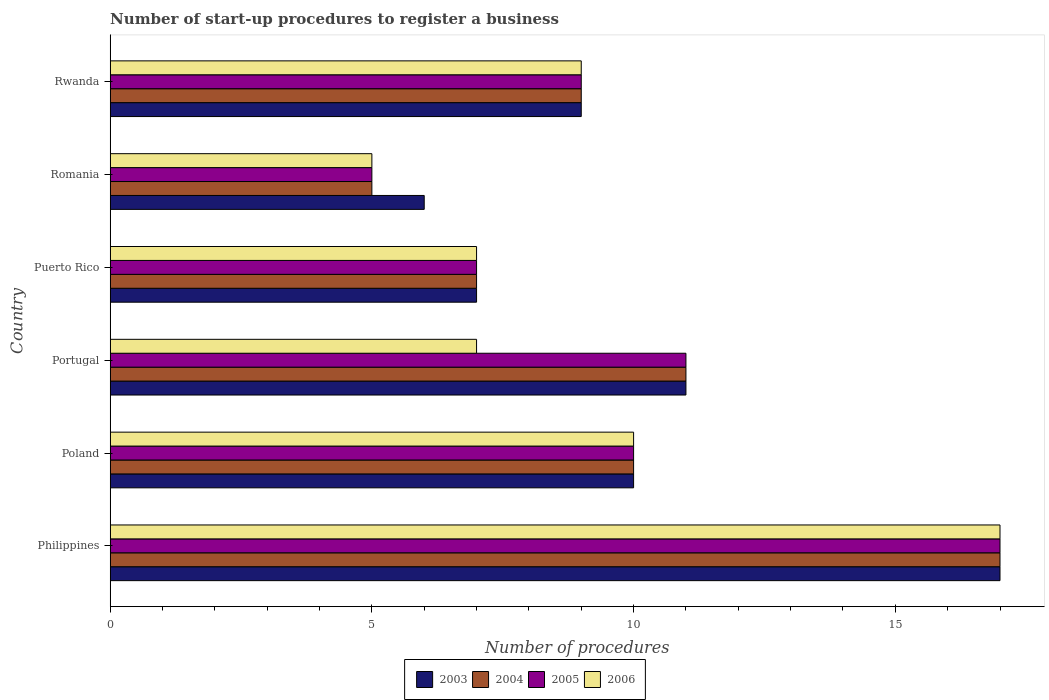How many groups of bars are there?
Offer a terse response. 6. Are the number of bars per tick equal to the number of legend labels?
Offer a very short reply. Yes. How many bars are there on the 4th tick from the top?
Keep it short and to the point. 4. How many bars are there on the 2nd tick from the bottom?
Your answer should be compact. 4. What is the label of the 2nd group of bars from the top?
Make the answer very short. Romania. Across all countries, what is the maximum number of procedures required to register a business in 2004?
Ensure brevity in your answer.  17. Across all countries, what is the minimum number of procedures required to register a business in 2006?
Your answer should be very brief. 5. In which country was the number of procedures required to register a business in 2003 maximum?
Offer a terse response. Philippines. In which country was the number of procedures required to register a business in 2004 minimum?
Your answer should be compact. Romania. What is the total number of procedures required to register a business in 2004 in the graph?
Provide a short and direct response. 59. What is the difference between the number of procedures required to register a business in 2005 in Poland and that in Portugal?
Your response must be concise. -1. What is the difference between the number of procedures required to register a business in 2005 in Poland and the number of procedures required to register a business in 2003 in Philippines?
Make the answer very short. -7. What is the average number of procedures required to register a business in 2004 per country?
Keep it short and to the point. 9.83. What is the ratio of the number of procedures required to register a business in 2003 in Poland to that in Portugal?
Your response must be concise. 0.91. Is the difference between the number of procedures required to register a business in 2004 in Romania and Rwanda greater than the difference between the number of procedures required to register a business in 2005 in Romania and Rwanda?
Provide a short and direct response. No. What is the difference between the highest and the second highest number of procedures required to register a business in 2005?
Make the answer very short. 6. Is the sum of the number of procedures required to register a business in 2005 in Puerto Rico and Romania greater than the maximum number of procedures required to register a business in 2003 across all countries?
Keep it short and to the point. No. Is it the case that in every country, the sum of the number of procedures required to register a business in 2005 and number of procedures required to register a business in 2006 is greater than the sum of number of procedures required to register a business in 2003 and number of procedures required to register a business in 2004?
Your response must be concise. No. Is it the case that in every country, the sum of the number of procedures required to register a business in 2005 and number of procedures required to register a business in 2004 is greater than the number of procedures required to register a business in 2006?
Make the answer very short. Yes. How many bars are there?
Provide a succinct answer. 24. What is the difference between two consecutive major ticks on the X-axis?
Ensure brevity in your answer.  5. Are the values on the major ticks of X-axis written in scientific E-notation?
Your answer should be compact. No. Does the graph contain grids?
Ensure brevity in your answer.  No. How are the legend labels stacked?
Your answer should be very brief. Horizontal. What is the title of the graph?
Your answer should be very brief. Number of start-up procedures to register a business. Does "1983" appear as one of the legend labels in the graph?
Keep it short and to the point. No. What is the label or title of the X-axis?
Offer a terse response. Number of procedures. What is the label or title of the Y-axis?
Provide a succinct answer. Country. What is the Number of procedures of 2004 in Philippines?
Ensure brevity in your answer.  17. What is the Number of procedures in 2005 in Philippines?
Provide a short and direct response. 17. What is the Number of procedures in 2006 in Philippines?
Keep it short and to the point. 17. What is the Number of procedures of 2004 in Poland?
Give a very brief answer. 10. What is the Number of procedures of 2004 in Portugal?
Your answer should be very brief. 11. What is the Number of procedures of 2006 in Puerto Rico?
Offer a terse response. 7. What is the Number of procedures of 2003 in Romania?
Ensure brevity in your answer.  6. What is the Number of procedures in 2004 in Romania?
Your answer should be compact. 5. What is the Number of procedures in 2006 in Romania?
Provide a short and direct response. 5. What is the Number of procedures of 2003 in Rwanda?
Your answer should be compact. 9. What is the Number of procedures in 2004 in Rwanda?
Make the answer very short. 9. What is the Number of procedures of 2005 in Rwanda?
Ensure brevity in your answer.  9. What is the Number of procedures in 2006 in Rwanda?
Offer a very short reply. 9. Across all countries, what is the maximum Number of procedures in 2005?
Provide a short and direct response. 17. Across all countries, what is the minimum Number of procedures in 2004?
Your response must be concise. 5. Across all countries, what is the minimum Number of procedures of 2005?
Provide a succinct answer. 5. Across all countries, what is the minimum Number of procedures in 2006?
Ensure brevity in your answer.  5. What is the total Number of procedures in 2006 in the graph?
Your answer should be compact. 55. What is the difference between the Number of procedures in 2003 in Philippines and that in Poland?
Offer a terse response. 7. What is the difference between the Number of procedures of 2004 in Philippines and that in Poland?
Offer a terse response. 7. What is the difference between the Number of procedures of 2006 in Philippines and that in Poland?
Give a very brief answer. 7. What is the difference between the Number of procedures of 2003 in Philippines and that in Portugal?
Offer a very short reply. 6. What is the difference between the Number of procedures of 2005 in Philippines and that in Portugal?
Your response must be concise. 6. What is the difference between the Number of procedures of 2006 in Philippines and that in Portugal?
Give a very brief answer. 10. What is the difference between the Number of procedures in 2003 in Philippines and that in Puerto Rico?
Your answer should be very brief. 10. What is the difference between the Number of procedures of 2006 in Philippines and that in Romania?
Give a very brief answer. 12. What is the difference between the Number of procedures of 2004 in Philippines and that in Rwanda?
Give a very brief answer. 8. What is the difference between the Number of procedures in 2006 in Philippines and that in Rwanda?
Give a very brief answer. 8. What is the difference between the Number of procedures of 2003 in Poland and that in Portugal?
Provide a short and direct response. -1. What is the difference between the Number of procedures of 2004 in Poland and that in Portugal?
Your answer should be compact. -1. What is the difference between the Number of procedures in 2005 in Poland and that in Portugal?
Make the answer very short. -1. What is the difference between the Number of procedures in 2006 in Poland and that in Portugal?
Your answer should be compact. 3. What is the difference between the Number of procedures in 2003 in Poland and that in Puerto Rico?
Keep it short and to the point. 3. What is the difference between the Number of procedures in 2005 in Poland and that in Puerto Rico?
Keep it short and to the point. 3. What is the difference between the Number of procedures in 2003 in Poland and that in Romania?
Offer a very short reply. 4. What is the difference between the Number of procedures of 2006 in Poland and that in Romania?
Provide a succinct answer. 5. What is the difference between the Number of procedures of 2003 in Poland and that in Rwanda?
Provide a short and direct response. 1. What is the difference between the Number of procedures of 2004 in Poland and that in Rwanda?
Provide a short and direct response. 1. What is the difference between the Number of procedures in 2005 in Poland and that in Rwanda?
Make the answer very short. 1. What is the difference between the Number of procedures in 2006 in Poland and that in Rwanda?
Your answer should be compact. 1. What is the difference between the Number of procedures of 2006 in Portugal and that in Puerto Rico?
Offer a terse response. 0. What is the difference between the Number of procedures in 2006 in Portugal and that in Romania?
Keep it short and to the point. 2. What is the difference between the Number of procedures in 2004 in Portugal and that in Rwanda?
Keep it short and to the point. 2. What is the difference between the Number of procedures of 2005 in Portugal and that in Rwanda?
Offer a terse response. 2. What is the difference between the Number of procedures of 2006 in Portugal and that in Rwanda?
Provide a succinct answer. -2. What is the difference between the Number of procedures of 2003 in Puerto Rico and that in Romania?
Provide a short and direct response. 1. What is the difference between the Number of procedures of 2005 in Puerto Rico and that in Romania?
Your answer should be very brief. 2. What is the difference between the Number of procedures in 2006 in Puerto Rico and that in Romania?
Offer a terse response. 2. What is the difference between the Number of procedures of 2003 in Puerto Rico and that in Rwanda?
Your answer should be very brief. -2. What is the difference between the Number of procedures of 2004 in Puerto Rico and that in Rwanda?
Provide a succinct answer. -2. What is the difference between the Number of procedures of 2003 in Romania and that in Rwanda?
Your response must be concise. -3. What is the difference between the Number of procedures of 2004 in Romania and that in Rwanda?
Give a very brief answer. -4. What is the difference between the Number of procedures of 2006 in Romania and that in Rwanda?
Offer a terse response. -4. What is the difference between the Number of procedures of 2003 in Philippines and the Number of procedures of 2004 in Poland?
Your answer should be compact. 7. What is the difference between the Number of procedures in 2003 in Philippines and the Number of procedures in 2005 in Poland?
Give a very brief answer. 7. What is the difference between the Number of procedures in 2003 in Philippines and the Number of procedures in 2006 in Poland?
Your answer should be very brief. 7. What is the difference between the Number of procedures in 2004 in Philippines and the Number of procedures in 2005 in Poland?
Your answer should be compact. 7. What is the difference between the Number of procedures in 2003 in Philippines and the Number of procedures in 2004 in Portugal?
Offer a terse response. 6. What is the difference between the Number of procedures in 2003 in Philippines and the Number of procedures in 2005 in Portugal?
Provide a succinct answer. 6. What is the difference between the Number of procedures in 2004 in Philippines and the Number of procedures in 2006 in Portugal?
Ensure brevity in your answer.  10. What is the difference between the Number of procedures in 2003 in Philippines and the Number of procedures in 2004 in Puerto Rico?
Your answer should be compact. 10. What is the difference between the Number of procedures in 2004 in Philippines and the Number of procedures in 2005 in Puerto Rico?
Offer a very short reply. 10. What is the difference between the Number of procedures in 2004 in Philippines and the Number of procedures in 2006 in Puerto Rico?
Your answer should be very brief. 10. What is the difference between the Number of procedures of 2003 in Philippines and the Number of procedures of 2004 in Romania?
Ensure brevity in your answer.  12. What is the difference between the Number of procedures in 2004 in Philippines and the Number of procedures in 2006 in Romania?
Ensure brevity in your answer.  12. What is the difference between the Number of procedures in 2004 in Poland and the Number of procedures in 2006 in Portugal?
Provide a succinct answer. 3. What is the difference between the Number of procedures of 2003 in Poland and the Number of procedures of 2005 in Puerto Rico?
Your answer should be very brief. 3. What is the difference between the Number of procedures in 2003 in Poland and the Number of procedures in 2006 in Puerto Rico?
Your answer should be compact. 3. What is the difference between the Number of procedures in 2004 in Poland and the Number of procedures in 2006 in Puerto Rico?
Offer a very short reply. 3. What is the difference between the Number of procedures of 2003 in Poland and the Number of procedures of 2005 in Romania?
Make the answer very short. 5. What is the difference between the Number of procedures in 2005 in Poland and the Number of procedures in 2006 in Romania?
Provide a succinct answer. 5. What is the difference between the Number of procedures of 2003 in Poland and the Number of procedures of 2004 in Rwanda?
Provide a succinct answer. 1. What is the difference between the Number of procedures of 2003 in Poland and the Number of procedures of 2005 in Rwanda?
Your response must be concise. 1. What is the difference between the Number of procedures in 2004 in Poland and the Number of procedures in 2005 in Rwanda?
Give a very brief answer. 1. What is the difference between the Number of procedures in 2005 in Poland and the Number of procedures in 2006 in Rwanda?
Offer a very short reply. 1. What is the difference between the Number of procedures of 2003 in Portugal and the Number of procedures of 2004 in Puerto Rico?
Your answer should be compact. 4. What is the difference between the Number of procedures of 2004 in Portugal and the Number of procedures of 2005 in Puerto Rico?
Your answer should be compact. 4. What is the difference between the Number of procedures of 2004 in Portugal and the Number of procedures of 2006 in Puerto Rico?
Your response must be concise. 4. What is the difference between the Number of procedures in 2003 in Portugal and the Number of procedures in 2004 in Romania?
Give a very brief answer. 6. What is the difference between the Number of procedures in 2003 in Portugal and the Number of procedures in 2005 in Romania?
Offer a terse response. 6. What is the difference between the Number of procedures of 2004 in Portugal and the Number of procedures of 2005 in Romania?
Offer a very short reply. 6. What is the difference between the Number of procedures of 2004 in Portugal and the Number of procedures of 2006 in Romania?
Give a very brief answer. 6. What is the difference between the Number of procedures in 2005 in Portugal and the Number of procedures in 2006 in Romania?
Ensure brevity in your answer.  6. What is the difference between the Number of procedures in 2003 in Puerto Rico and the Number of procedures in 2004 in Romania?
Offer a terse response. 2. What is the difference between the Number of procedures of 2003 in Puerto Rico and the Number of procedures of 2005 in Romania?
Ensure brevity in your answer.  2. What is the difference between the Number of procedures in 2003 in Puerto Rico and the Number of procedures in 2006 in Romania?
Your answer should be compact. 2. What is the difference between the Number of procedures of 2004 in Puerto Rico and the Number of procedures of 2005 in Romania?
Keep it short and to the point. 2. What is the difference between the Number of procedures of 2004 in Puerto Rico and the Number of procedures of 2006 in Romania?
Your answer should be compact. 2. What is the difference between the Number of procedures in 2003 in Puerto Rico and the Number of procedures in 2005 in Rwanda?
Make the answer very short. -2. What is the difference between the Number of procedures of 2003 in Puerto Rico and the Number of procedures of 2006 in Rwanda?
Your answer should be very brief. -2. What is the difference between the Number of procedures in 2004 in Puerto Rico and the Number of procedures in 2006 in Rwanda?
Offer a very short reply. -2. What is the difference between the Number of procedures in 2003 in Romania and the Number of procedures in 2004 in Rwanda?
Give a very brief answer. -3. What is the difference between the Number of procedures in 2004 in Romania and the Number of procedures in 2005 in Rwanda?
Keep it short and to the point. -4. What is the difference between the Number of procedures of 2004 in Romania and the Number of procedures of 2006 in Rwanda?
Your response must be concise. -4. What is the difference between the Number of procedures of 2005 in Romania and the Number of procedures of 2006 in Rwanda?
Your answer should be compact. -4. What is the average Number of procedures in 2004 per country?
Provide a succinct answer. 9.83. What is the average Number of procedures of 2005 per country?
Offer a terse response. 9.83. What is the average Number of procedures in 2006 per country?
Ensure brevity in your answer.  9.17. What is the difference between the Number of procedures of 2003 and Number of procedures of 2005 in Philippines?
Your response must be concise. 0. What is the difference between the Number of procedures of 2003 and Number of procedures of 2006 in Philippines?
Offer a terse response. 0. What is the difference between the Number of procedures of 2004 and Number of procedures of 2006 in Philippines?
Offer a very short reply. 0. What is the difference between the Number of procedures in 2003 and Number of procedures in 2006 in Poland?
Ensure brevity in your answer.  0. What is the difference between the Number of procedures of 2004 and Number of procedures of 2005 in Poland?
Give a very brief answer. 0. What is the difference between the Number of procedures in 2004 and Number of procedures in 2006 in Poland?
Offer a terse response. 0. What is the difference between the Number of procedures in 2003 and Number of procedures in 2005 in Portugal?
Keep it short and to the point. 0. What is the difference between the Number of procedures of 2004 and Number of procedures of 2005 in Portugal?
Ensure brevity in your answer.  0. What is the difference between the Number of procedures in 2004 and Number of procedures in 2006 in Portugal?
Provide a short and direct response. 4. What is the difference between the Number of procedures of 2003 and Number of procedures of 2006 in Puerto Rico?
Your answer should be very brief. 0. What is the difference between the Number of procedures in 2005 and Number of procedures in 2006 in Puerto Rico?
Offer a very short reply. 0. What is the difference between the Number of procedures in 2003 and Number of procedures in 2005 in Romania?
Give a very brief answer. 1. What is the difference between the Number of procedures in 2003 and Number of procedures in 2006 in Romania?
Your response must be concise. 1. What is the difference between the Number of procedures of 2004 and Number of procedures of 2005 in Rwanda?
Give a very brief answer. 0. What is the difference between the Number of procedures of 2005 and Number of procedures of 2006 in Rwanda?
Your response must be concise. 0. What is the ratio of the Number of procedures in 2004 in Philippines to that in Poland?
Provide a short and direct response. 1.7. What is the ratio of the Number of procedures of 2006 in Philippines to that in Poland?
Make the answer very short. 1.7. What is the ratio of the Number of procedures in 2003 in Philippines to that in Portugal?
Keep it short and to the point. 1.55. What is the ratio of the Number of procedures in 2004 in Philippines to that in Portugal?
Offer a very short reply. 1.55. What is the ratio of the Number of procedures of 2005 in Philippines to that in Portugal?
Your answer should be compact. 1.55. What is the ratio of the Number of procedures of 2006 in Philippines to that in Portugal?
Your response must be concise. 2.43. What is the ratio of the Number of procedures in 2003 in Philippines to that in Puerto Rico?
Offer a very short reply. 2.43. What is the ratio of the Number of procedures of 2004 in Philippines to that in Puerto Rico?
Provide a short and direct response. 2.43. What is the ratio of the Number of procedures of 2005 in Philippines to that in Puerto Rico?
Make the answer very short. 2.43. What is the ratio of the Number of procedures of 2006 in Philippines to that in Puerto Rico?
Provide a succinct answer. 2.43. What is the ratio of the Number of procedures of 2003 in Philippines to that in Romania?
Keep it short and to the point. 2.83. What is the ratio of the Number of procedures of 2004 in Philippines to that in Romania?
Your answer should be compact. 3.4. What is the ratio of the Number of procedures in 2005 in Philippines to that in Romania?
Your response must be concise. 3.4. What is the ratio of the Number of procedures of 2003 in Philippines to that in Rwanda?
Make the answer very short. 1.89. What is the ratio of the Number of procedures in 2004 in Philippines to that in Rwanda?
Give a very brief answer. 1.89. What is the ratio of the Number of procedures in 2005 in Philippines to that in Rwanda?
Make the answer very short. 1.89. What is the ratio of the Number of procedures in 2006 in Philippines to that in Rwanda?
Ensure brevity in your answer.  1.89. What is the ratio of the Number of procedures of 2003 in Poland to that in Portugal?
Your answer should be compact. 0.91. What is the ratio of the Number of procedures of 2004 in Poland to that in Portugal?
Provide a succinct answer. 0.91. What is the ratio of the Number of procedures in 2005 in Poland to that in Portugal?
Give a very brief answer. 0.91. What is the ratio of the Number of procedures in 2006 in Poland to that in Portugal?
Offer a very short reply. 1.43. What is the ratio of the Number of procedures in 2003 in Poland to that in Puerto Rico?
Your answer should be compact. 1.43. What is the ratio of the Number of procedures in 2004 in Poland to that in Puerto Rico?
Ensure brevity in your answer.  1.43. What is the ratio of the Number of procedures in 2005 in Poland to that in Puerto Rico?
Give a very brief answer. 1.43. What is the ratio of the Number of procedures in 2006 in Poland to that in Puerto Rico?
Keep it short and to the point. 1.43. What is the ratio of the Number of procedures of 2003 in Poland to that in Romania?
Your response must be concise. 1.67. What is the ratio of the Number of procedures of 2004 in Poland to that in Romania?
Your answer should be very brief. 2. What is the ratio of the Number of procedures in 2005 in Poland to that in Romania?
Offer a terse response. 2. What is the ratio of the Number of procedures in 2006 in Poland to that in Romania?
Provide a short and direct response. 2. What is the ratio of the Number of procedures in 2003 in Portugal to that in Puerto Rico?
Offer a terse response. 1.57. What is the ratio of the Number of procedures of 2004 in Portugal to that in Puerto Rico?
Keep it short and to the point. 1.57. What is the ratio of the Number of procedures of 2005 in Portugal to that in Puerto Rico?
Your response must be concise. 1.57. What is the ratio of the Number of procedures of 2003 in Portugal to that in Romania?
Offer a terse response. 1.83. What is the ratio of the Number of procedures of 2006 in Portugal to that in Romania?
Your response must be concise. 1.4. What is the ratio of the Number of procedures of 2003 in Portugal to that in Rwanda?
Your answer should be compact. 1.22. What is the ratio of the Number of procedures in 2004 in Portugal to that in Rwanda?
Ensure brevity in your answer.  1.22. What is the ratio of the Number of procedures in 2005 in Portugal to that in Rwanda?
Provide a succinct answer. 1.22. What is the ratio of the Number of procedures in 2004 in Puerto Rico to that in Romania?
Offer a very short reply. 1.4. What is the ratio of the Number of procedures of 2005 in Puerto Rico to that in Romania?
Your response must be concise. 1.4. What is the ratio of the Number of procedures of 2004 in Puerto Rico to that in Rwanda?
Your answer should be compact. 0.78. What is the ratio of the Number of procedures in 2005 in Puerto Rico to that in Rwanda?
Your response must be concise. 0.78. What is the ratio of the Number of procedures in 2006 in Puerto Rico to that in Rwanda?
Your answer should be compact. 0.78. What is the ratio of the Number of procedures in 2003 in Romania to that in Rwanda?
Provide a succinct answer. 0.67. What is the ratio of the Number of procedures in 2004 in Romania to that in Rwanda?
Provide a succinct answer. 0.56. What is the ratio of the Number of procedures in 2005 in Romania to that in Rwanda?
Your response must be concise. 0.56. What is the ratio of the Number of procedures of 2006 in Romania to that in Rwanda?
Provide a short and direct response. 0.56. What is the difference between the highest and the second highest Number of procedures in 2003?
Provide a short and direct response. 6. What is the difference between the highest and the second highest Number of procedures in 2004?
Provide a succinct answer. 6. 